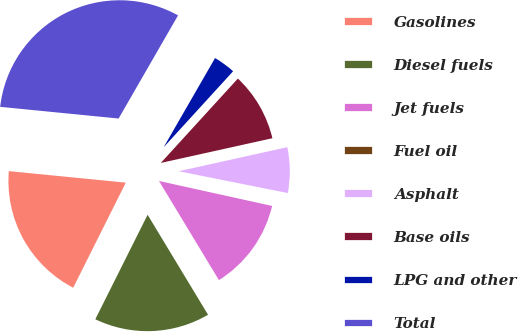Convert chart to OTSL. <chart><loc_0><loc_0><loc_500><loc_500><pie_chart><fcel>Gasolines<fcel>Diesel fuels<fcel>Jet fuels<fcel>Fuel oil<fcel>Asphalt<fcel>Base oils<fcel>LPG and other<fcel>Total<nl><fcel>19.18%<fcel>16.04%<fcel>12.89%<fcel>0.32%<fcel>6.61%<fcel>9.75%<fcel>3.46%<fcel>31.76%<nl></chart> 